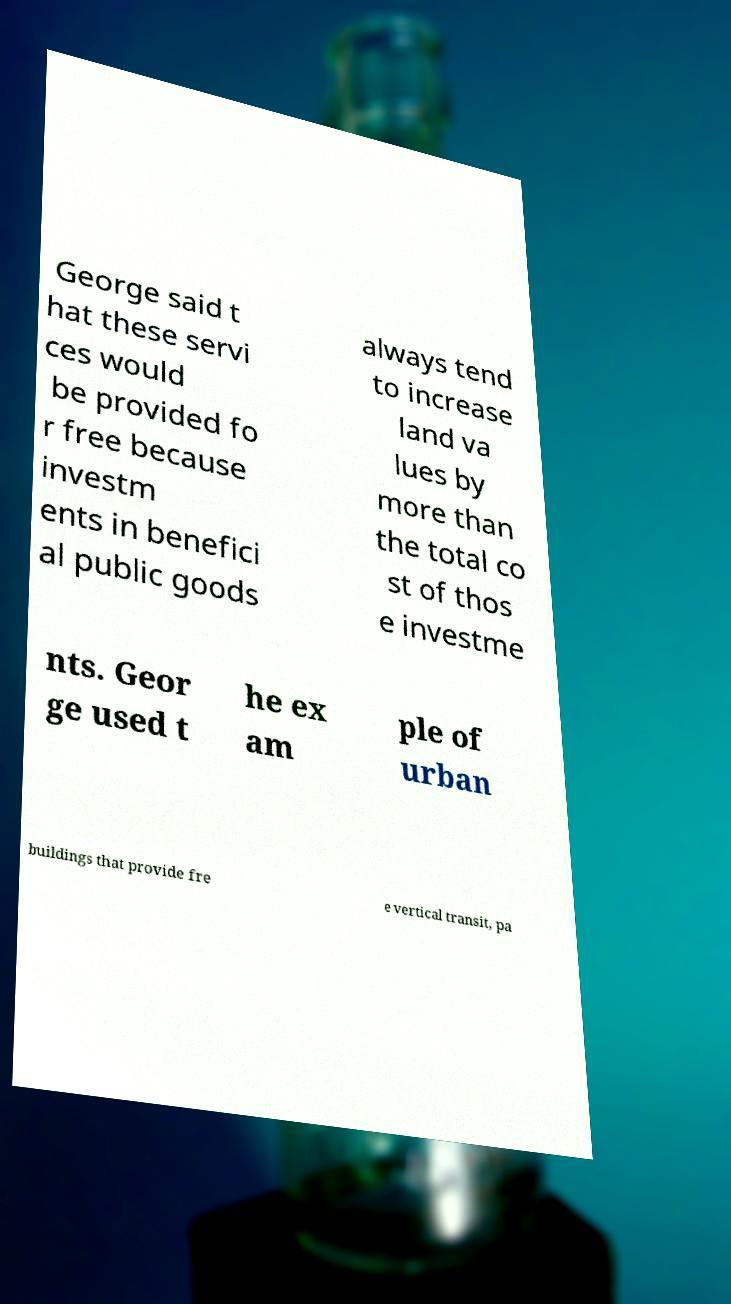Can you read and provide the text displayed in the image?This photo seems to have some interesting text. Can you extract and type it out for me? George said t hat these servi ces would be provided fo r free because investm ents in benefici al public goods always tend to increase land va lues by more than the total co st of thos e investme nts. Geor ge used t he ex am ple of urban buildings that provide fre e vertical transit, pa 